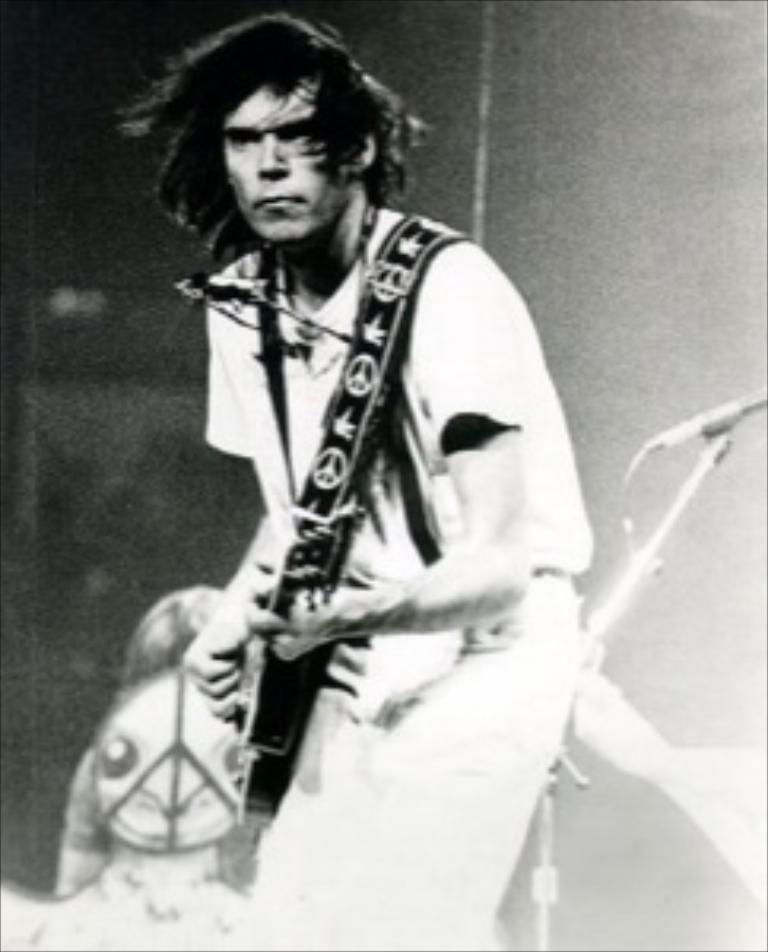What is the main subject of the image? There is a person in the image. What is the person doing in the image? The person is standing and playing a guitar. What object is near the person? There is a microphone near the person. What type of lumber is the person using to play the guitar in the image? The person is not using any lumber to play the guitar in the image; they are using a guitar, which is a musical instrument. What holiday is the person celebrating in the image? There is no indication of a holiday in the image; it simply shows a person playing a guitar with a microphone nearby. 